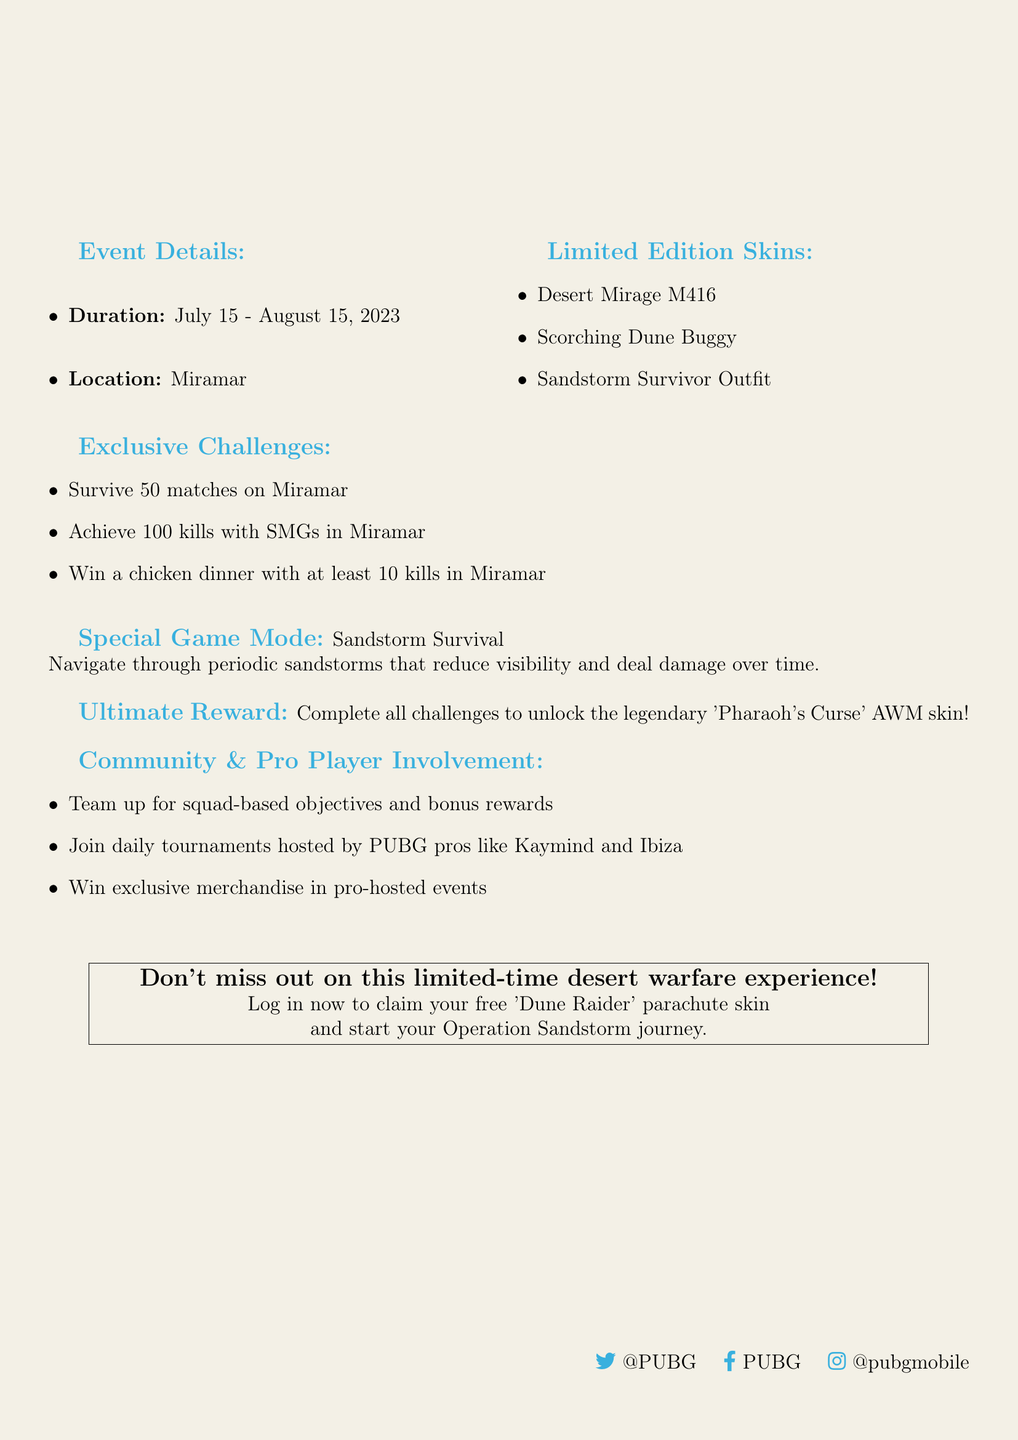What is the event duration? The event duration is specifically mentioned in the document as from July 15 to August 15, 2023.
Answer: July 15 - August 15, 2023 What is the name of the special game mode? The document specifies the new game mode introduced during the event, which is "Sandstorm Survival."
Answer: Sandstorm Survival How many exclusive challenges are there? The number of exclusive challenges listed in the document totals three.
Answer: Three What is the reward for completing all challenges? The document states that completing all challenges unlocks the "Pharaoh's Curse" AWM skin.
Answer: Pharaoh's Curse AWM skin Which famous players are involved in the daily tournaments? The document identifies Kaymind and Ibiza as the PUBG pros hosting the daily tournaments.
Answer: Kaymind and Ibiza How many matches must you survive on Miramar to complete one of the challenges? The document reveals that players must survive 50 matches in Miramar to meet one of the challenge requirements.
Answer: 50 matches What is the first limited edition skin mentioned? The document lists the "Desert Mirage M416" as the first skin in the limited edition skins section.
Answer: Desert Mirage M416 What kind of gameplay element do periodic sandstorms present? The document explains that periodic sandstorms reduce visibility and deal damage over time during the special game mode.
Answer: Reduce visibility and deal damage over time 